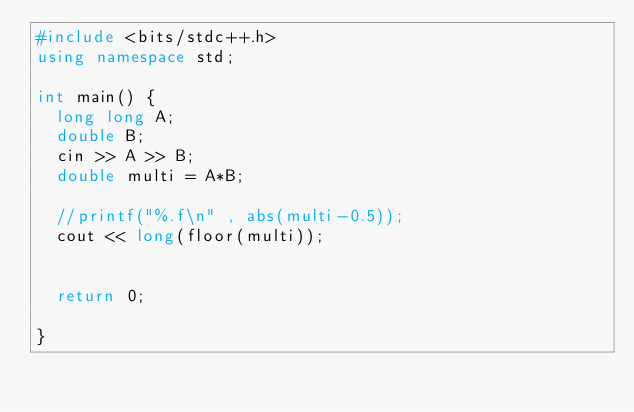<code> <loc_0><loc_0><loc_500><loc_500><_C++_>#include <bits/stdc++.h>
using namespace std;

int main() {
  long long A;
  double B;
  cin >> A >> B;
  double multi = A*B;
  
  //printf("%.f\n" , abs(multi-0.5));
  cout << long(floor(multi));

  
  return 0;

}
</code> 